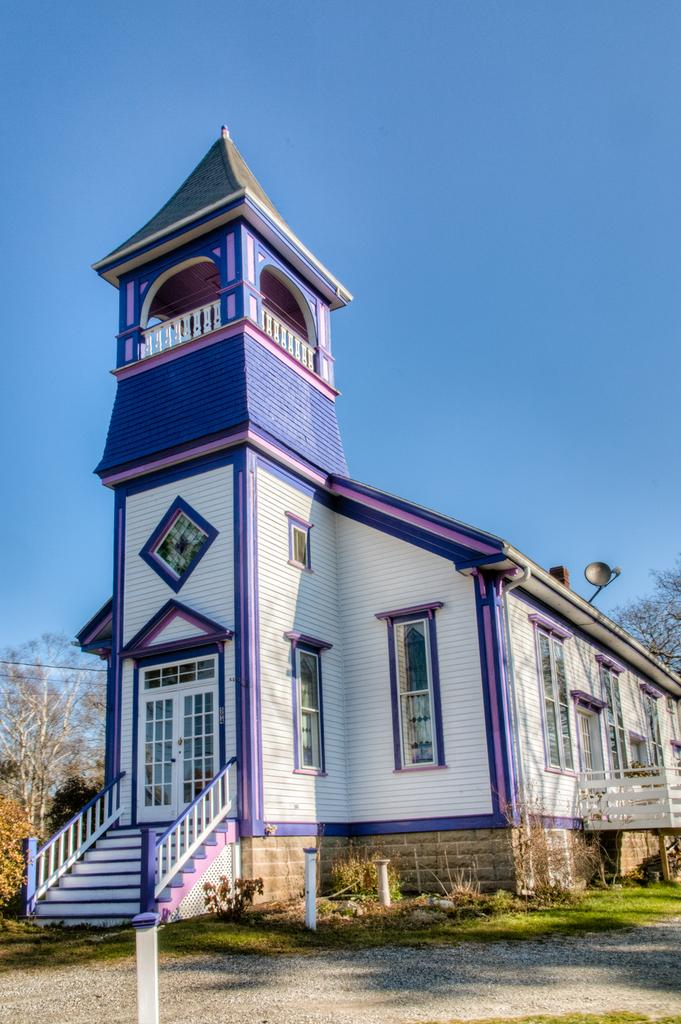What type of structure is present in the image? There is a house in the image. Can you describe the surroundings of the house? There is a path to the side of the house and trees in the background of the image. What can be seen in the sky in the image? The sky is visible in the background of the image. What type of sign is hanging from the tree in the image? There is no sign present in the image; it only features a house, a path, trees, and the sky. 